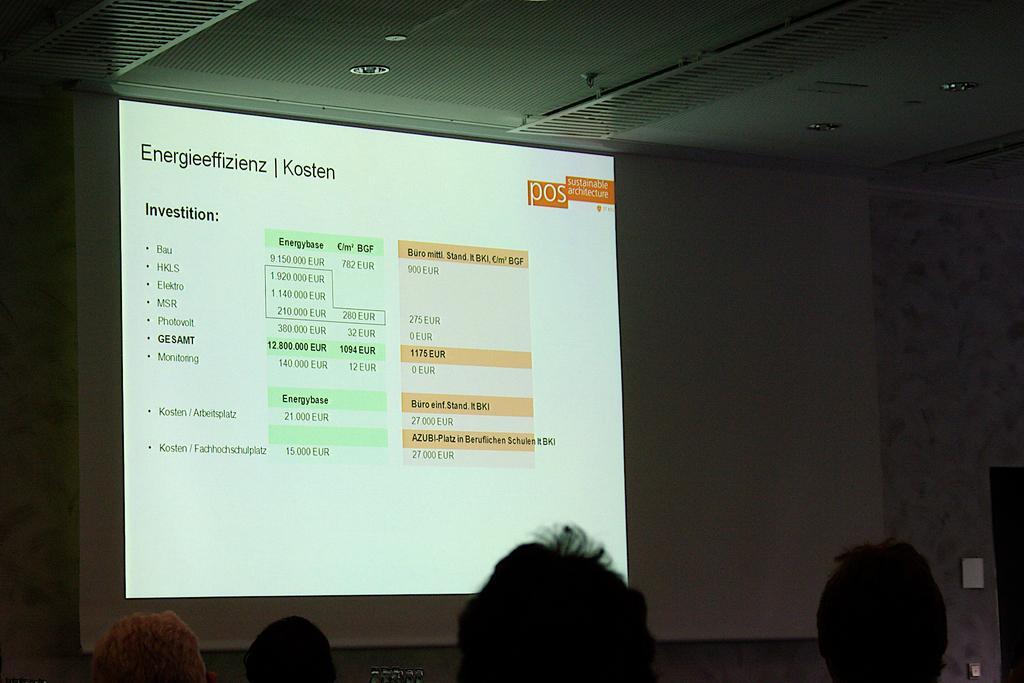How would you summarize this image in a sentence or two? In this picture we can see some people and in front of them we can see a screen, wall and some objects. 